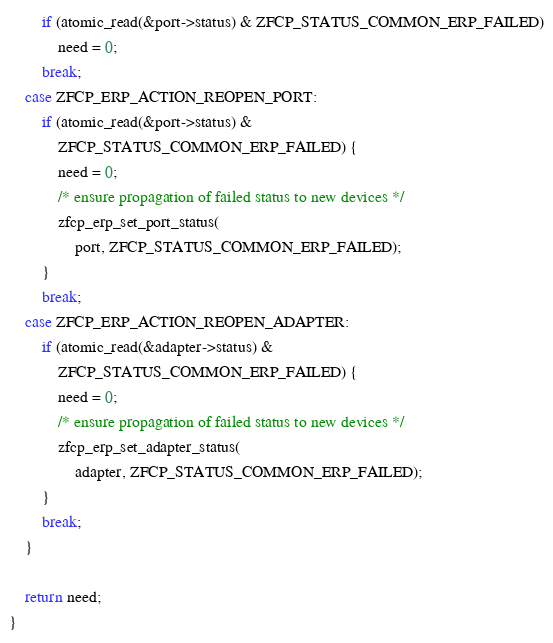Convert code to text. <code><loc_0><loc_0><loc_500><loc_500><_C_>		if (atomic_read(&port->status) & ZFCP_STATUS_COMMON_ERP_FAILED)
			need = 0;
		break;
	case ZFCP_ERP_ACTION_REOPEN_PORT:
		if (atomic_read(&port->status) &
		    ZFCP_STATUS_COMMON_ERP_FAILED) {
			need = 0;
			/* ensure propagation of failed status to new devices */
			zfcp_erp_set_port_status(
				port, ZFCP_STATUS_COMMON_ERP_FAILED);
		}
		break;
	case ZFCP_ERP_ACTION_REOPEN_ADAPTER:
		if (atomic_read(&adapter->status) &
		    ZFCP_STATUS_COMMON_ERP_FAILED) {
			need = 0;
			/* ensure propagation of failed status to new devices */
			zfcp_erp_set_adapter_status(
				adapter, ZFCP_STATUS_COMMON_ERP_FAILED);
		}
		break;
	}

	return need;
}
</code> 